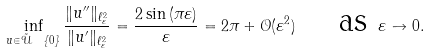Convert formula to latex. <formula><loc_0><loc_0><loc_500><loc_500>\inf _ { u \in \mathcal { \tilde { U } } \ \{ 0 \} } \frac { \| u ^ { \prime \prime } \| _ { \ell ^ { 2 } _ { \varepsilon } } } { \| u ^ { \prime } \| _ { \ell ^ { 2 } _ { \varepsilon } } } = \frac { 2 \sin { ( \pi \varepsilon ) } } { \varepsilon } = 2 \pi + \mathcal { O } ( \varepsilon ^ { 2 } ) \quad \text { as } \varepsilon \to 0 .</formula> 